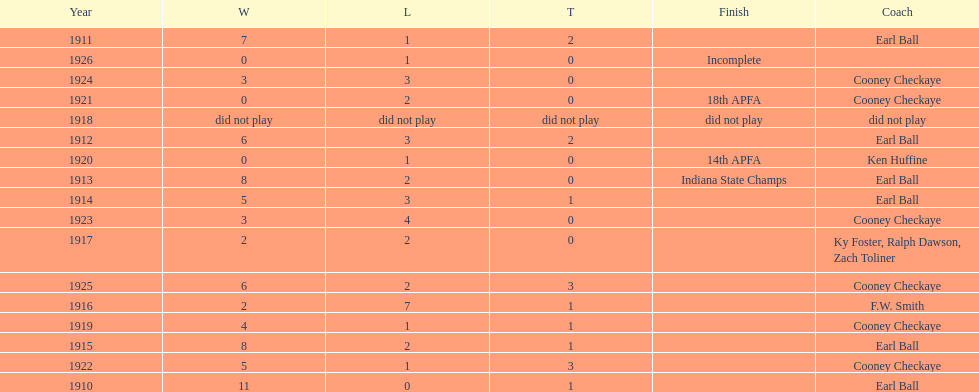In what year did the muncie flyers have an undefeated record? 1910. Would you be able to parse every entry in this table? {'header': ['Year', 'W', 'L', 'T', 'Finish', 'Coach'], 'rows': [['1911', '7', '1', '2', '', 'Earl Ball'], ['1926', '0', '1', '0', 'Incomplete', ''], ['1924', '3', '3', '0', '', 'Cooney Checkaye'], ['1921', '0', '2', '0', '18th APFA', 'Cooney Checkaye'], ['1918', 'did not play', 'did not play', 'did not play', 'did not play', 'did not play'], ['1912', '6', '3', '2', '', 'Earl Ball'], ['1920', '0', '1', '0', '14th APFA', 'Ken Huffine'], ['1913', '8', '2', '0', 'Indiana State Champs', 'Earl Ball'], ['1914', '5', '3', '1', '', 'Earl Ball'], ['1923', '3', '4', '0', '', 'Cooney Checkaye'], ['1917', '2', '2', '0', '', 'Ky Foster, Ralph Dawson, Zach Toliner'], ['1925', '6', '2', '3', '', 'Cooney Checkaye'], ['1916', '2', '7', '1', '', 'F.W. Smith'], ['1919', '4', '1', '1', '', 'Cooney Checkaye'], ['1915', '8', '2', '1', '', 'Earl Ball'], ['1922', '5', '1', '3', '', 'Cooney Checkaye'], ['1910', '11', '0', '1', '', 'Earl Ball']]} 